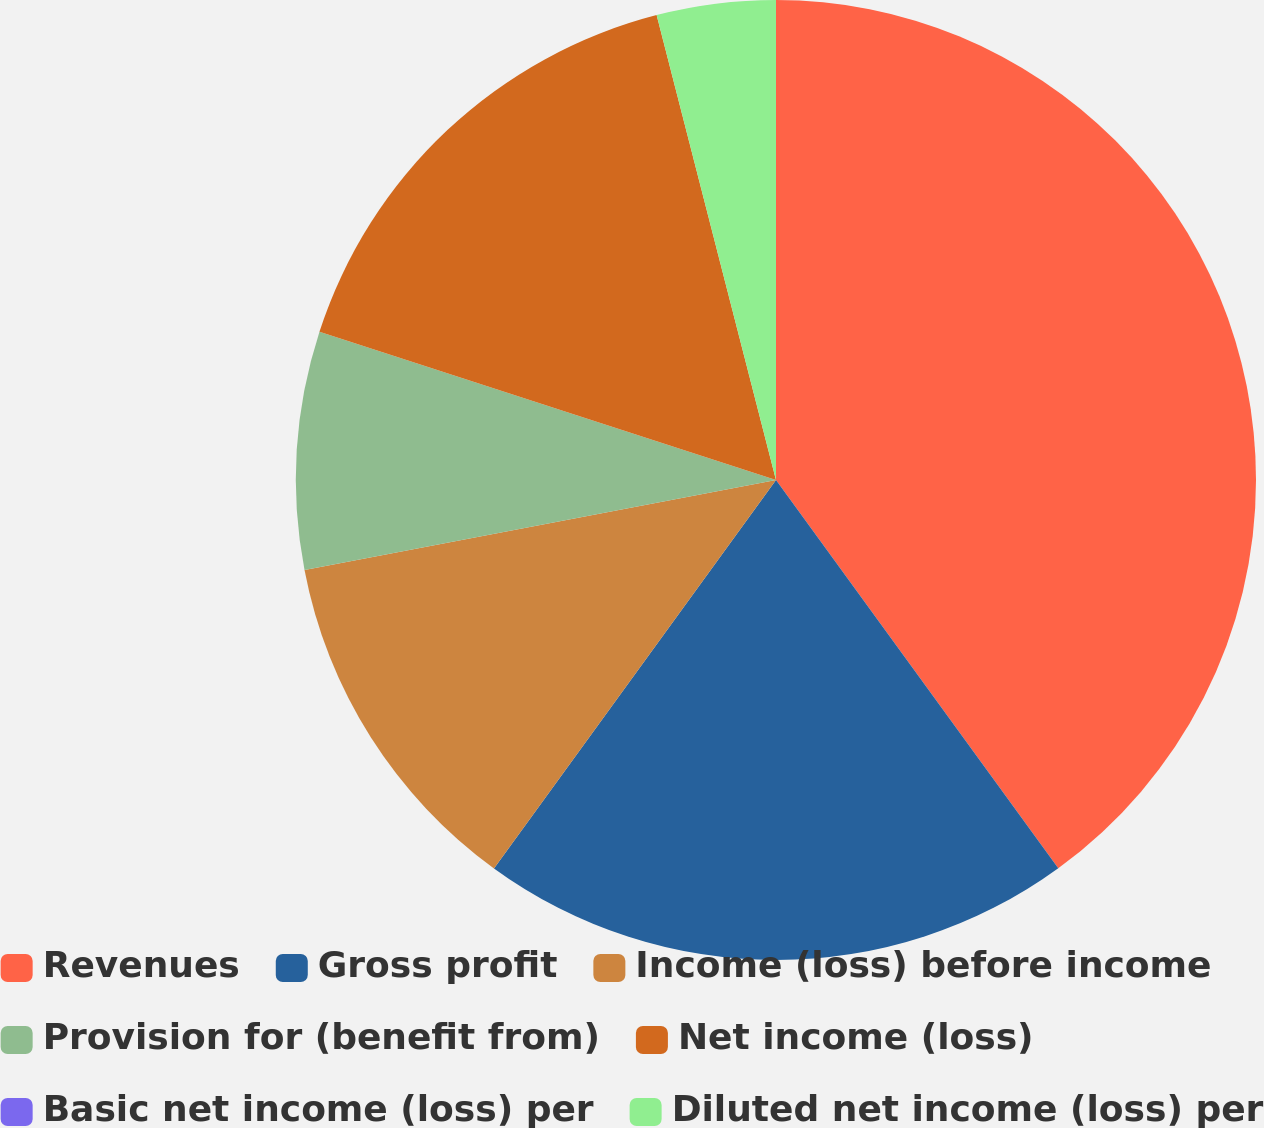Convert chart to OTSL. <chart><loc_0><loc_0><loc_500><loc_500><pie_chart><fcel>Revenues<fcel>Gross profit<fcel>Income (loss) before income<fcel>Provision for (benefit from)<fcel>Net income (loss)<fcel>Basic net income (loss) per<fcel>Diluted net income (loss) per<nl><fcel>39.99%<fcel>20.0%<fcel>12.0%<fcel>8.0%<fcel>16.0%<fcel>0.0%<fcel>4.0%<nl></chart> 